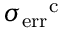Convert formula to latex. <formula><loc_0><loc_0><loc_500><loc_500>\sigma _ { e r r } ^ { c }</formula> 